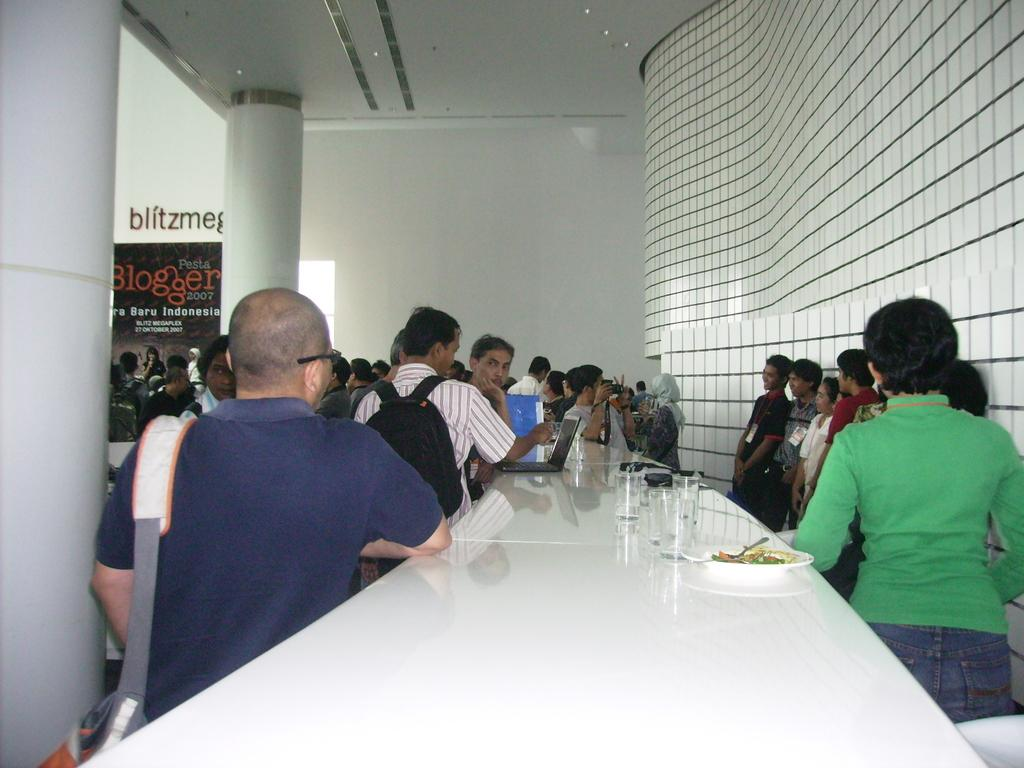What are the people in the image doing? The group of people is standing in a line. What objects can be seen in the image besides the people? There is a glass, a bowl, a spoon, and food on a plate in the image. What might be used for eating or serving in the image? The spoon and the plate can be used for eating or serving. What is visible in the background of the image? There is a poster in the background of the image. What type of pigs can be seen eating cabbage in the image? There are no pigs or cabbage present in the image. How does the digestion process of the people in the image compare to that of pigs? There is no information about the digestion process of the people or pigs in the image, as it does not depict any such activity. 